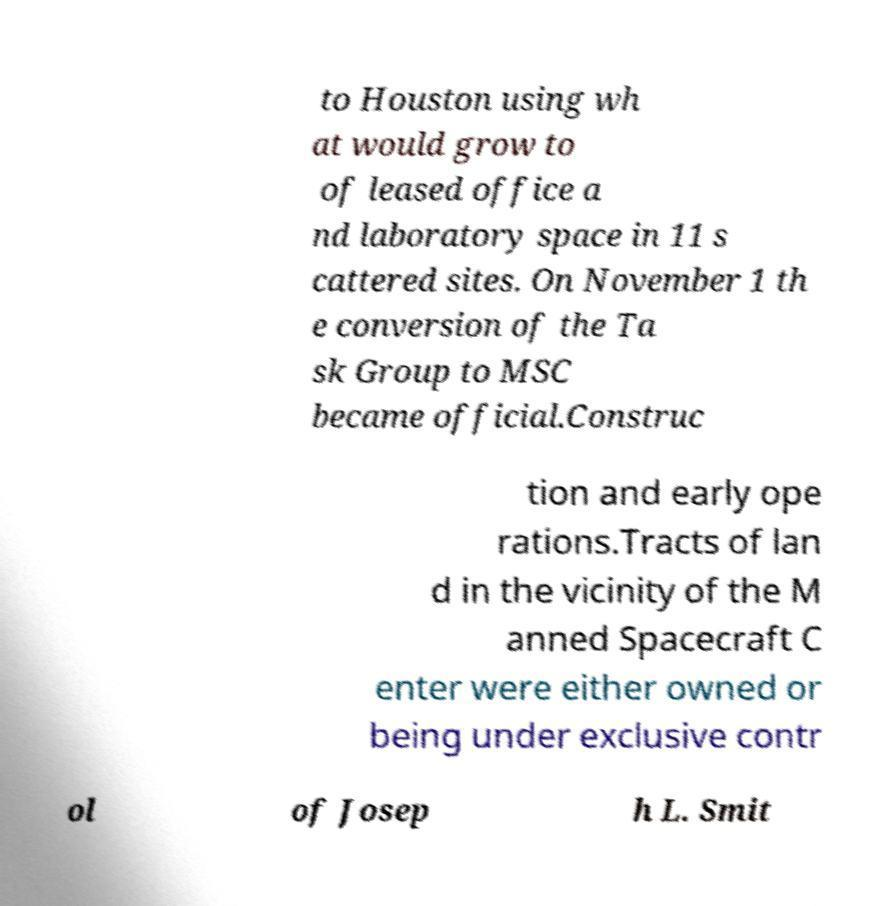Please read and relay the text visible in this image. What does it say? to Houston using wh at would grow to of leased office a nd laboratory space in 11 s cattered sites. On November 1 th e conversion of the Ta sk Group to MSC became official.Construc tion and early ope rations.Tracts of lan d in the vicinity of the M anned Spacecraft C enter were either owned or being under exclusive contr ol of Josep h L. Smit 